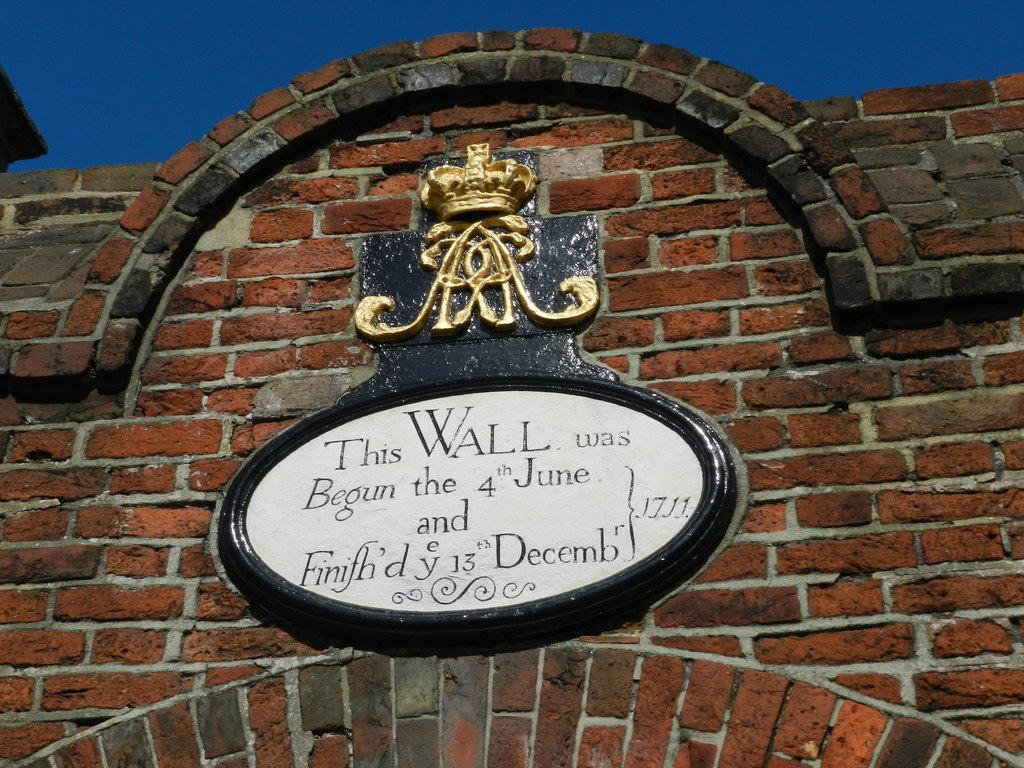What is on the wall in the image? There is a name board on the wall in the image. What can be seen in the background of the image? The sky is visible in the background of the image. How many competitors participated in the competition shown in the image? There is no competition present in the image; it only features a name board on the wall and the sky in the background. 